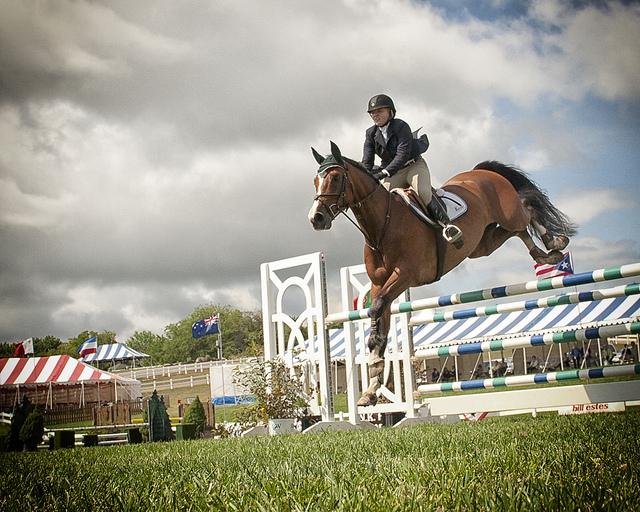Is this horse in a race?
Write a very short answer. Yes. What is the horse doing?
Give a very brief answer. Jumping. What color is the horse?
Quick response, please. Brown. What kind of animal is that?
Answer briefly. Horse. Who is riding the horse?
Short answer required. Jockey. 